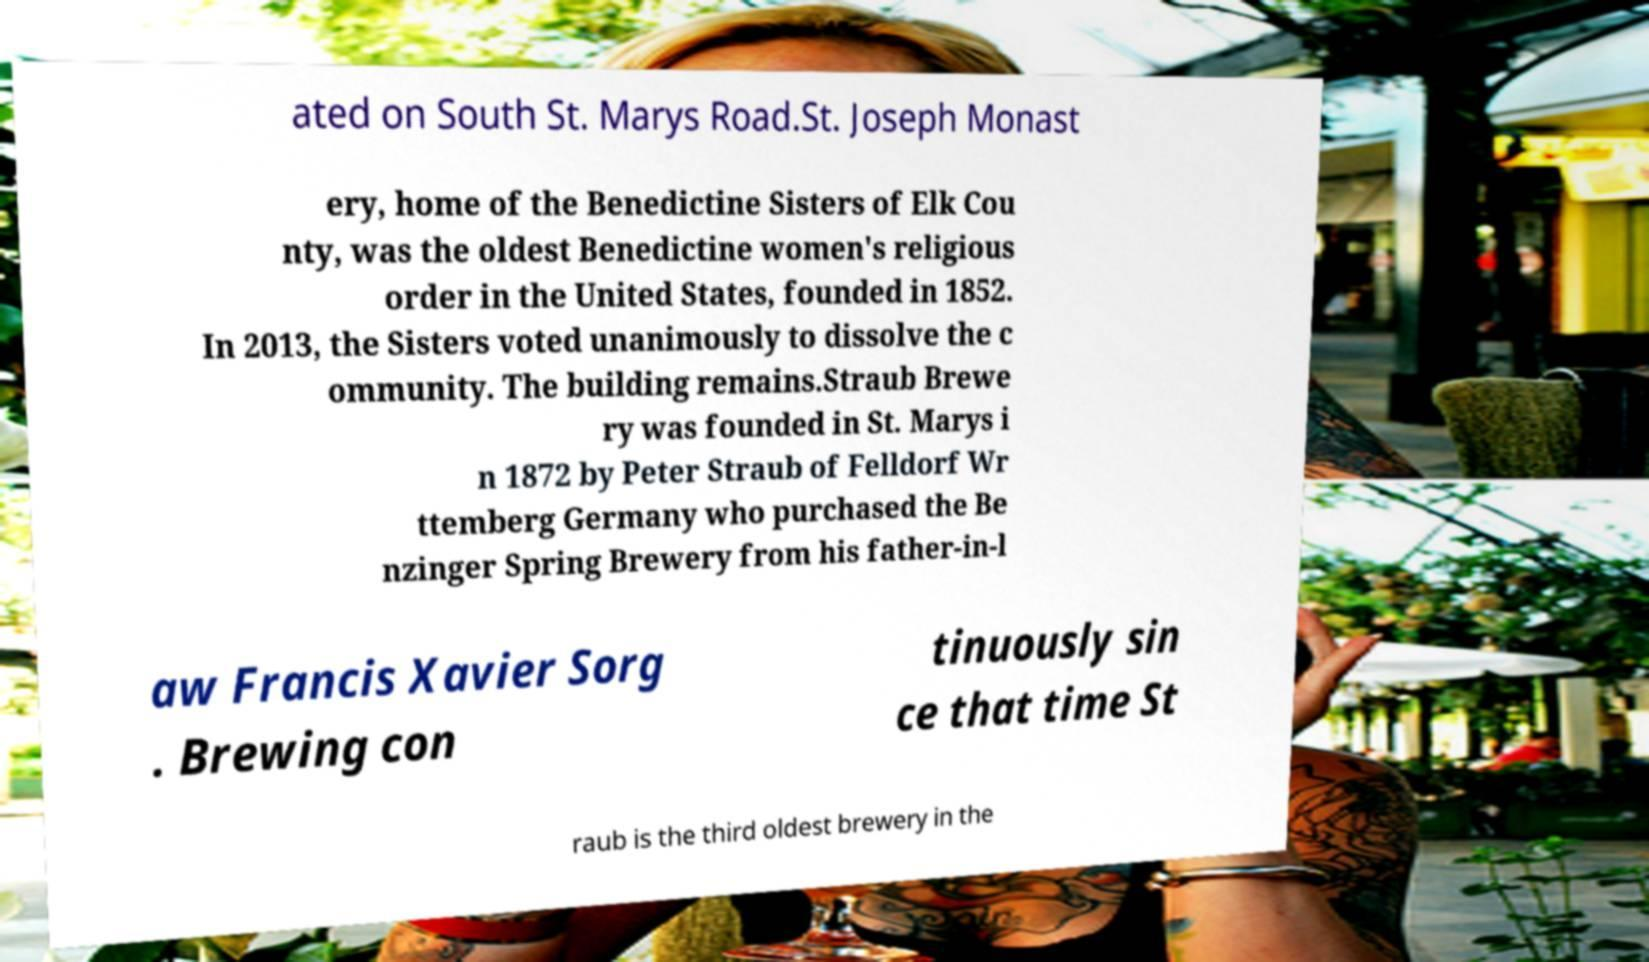Please read and relay the text visible in this image. What does it say? ated on South St. Marys Road.St. Joseph Monast ery, home of the Benedictine Sisters of Elk Cou nty, was the oldest Benedictine women's religious order in the United States, founded in 1852. In 2013, the Sisters voted unanimously to dissolve the c ommunity. The building remains.Straub Brewe ry was founded in St. Marys i n 1872 by Peter Straub of Felldorf Wr ttemberg Germany who purchased the Be nzinger Spring Brewery from his father-in-l aw Francis Xavier Sorg . Brewing con tinuously sin ce that time St raub is the third oldest brewery in the 